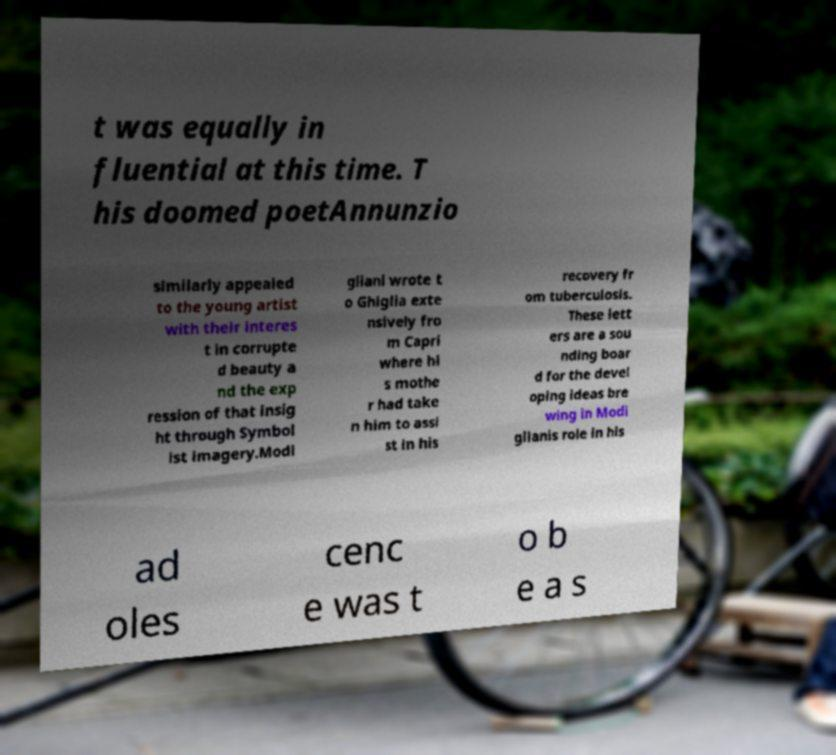Could you extract and type out the text from this image? t was equally in fluential at this time. T his doomed poetAnnunzio similarly appealed to the young artist with their interes t in corrupte d beauty a nd the exp ression of that insig ht through Symbol ist imagery.Modi gliani wrote t o Ghiglia exte nsively fro m Capri where hi s mothe r had take n him to assi st in his recovery fr om tuberculosis. These lett ers are a sou nding boar d for the devel oping ideas bre wing in Modi glianis role in his ad oles cenc e was t o b e a s 